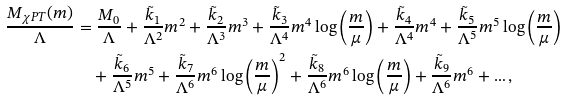Convert formula to latex. <formula><loc_0><loc_0><loc_500><loc_500>\frac { M _ { \chi P T } ( m ) } { \Lambda } & = \frac { M _ { 0 } } { \Lambda } + \frac { \tilde { k } _ { 1 } } { \Lambda ^ { 2 } } m ^ { 2 } + \frac { \tilde { k } _ { 2 } } { \Lambda ^ { 3 } } m ^ { 3 } + \frac { \tilde { k } _ { 3 } } { \Lambda ^ { 4 } } m ^ { 4 } \log \left ( \frac { m } { \mu } \right ) + \frac { \tilde { k } _ { 4 } } { \Lambda ^ { 4 } } m ^ { 4 } + \frac { \tilde { k } _ { 5 } } { \Lambda ^ { 5 } } m ^ { 5 } \log \left ( \frac { m } { \mu } \right ) \\ & \quad + \frac { \tilde { k } _ { 6 } } { \Lambda ^ { 5 } } m ^ { 5 } + \frac { \tilde { k } _ { 7 } } { \Lambda ^ { 6 } } m ^ { 6 } \log \left ( \frac { m } { \mu } \right ) ^ { 2 } + \frac { \tilde { k } _ { 8 } } { \Lambda ^ { 6 } } m ^ { 6 } \log \left ( \frac { m } { \mu } \right ) + \frac { \tilde { k } _ { 9 } } { \Lambda ^ { 6 } } m ^ { 6 } + \dots ,</formula> 